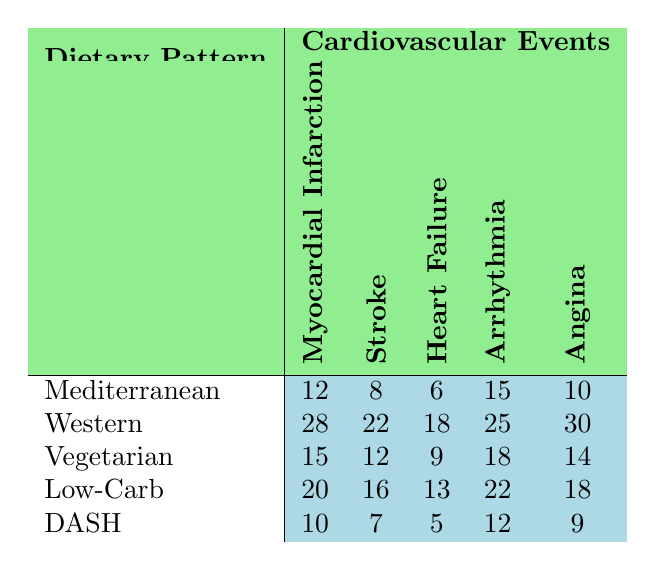What is the frequency of myocardial infarction in the Western dietary pattern? The table shows that for the Western dietary pattern, the frequency of myocardial infarction is listed as 28.
Answer: 28 Which dietary pattern has the highest rate of angina? By comparing the angina values, the Western dietary pattern has the highest value at 30, which is greater than the next highest, Low-Carb at 18.
Answer: Western What is the total number of strokes across all dietary patterns? To find the total strokes, add the values: 8 (Mediterranean) + 22 (Western) + 12 (Vegetarian) + 16 (Low-Carb) + 7 (DASH) = 65.
Answer: 65 Is the frequency of heart failure in the Mediterranean diet higher than that in the DASH diet? In the Mediterranean diet, the frequency of heart failure is 6, while in the DASH diet, it is 5. Since 6 is greater than 5, this statement is true.
Answer: Yes What is the average frequency of arrhythmia across all dietary patterns? First, sum the arrhythmia values: 15 (Mediterranean) + 25 (Western) + 18 (Vegetarian) + 22 (Low-Carb) + 12 (DASH) = 92. There are 5 dietary patterns, so the average is 92/5 = 18.4.
Answer: 18.4 Which dietary pattern has the lowest incidence of heart failure? Looking at the heart failure values, DASH has the lowest frequency at 5, which is less than all other dietary patterns.
Answer: DASH What is the difference in the number of strokes between the Western and the Mediterranean diets? The Western diet has 22 strokes while the Mediterranean has 8. The difference is 22 - 8 = 14.
Answer: 14 How does the frequency of myocardial infarction in the Vegetarian diet compare to that in the Mediterranean diet? The Vegetarian diet's frequency of myocardial infarction is 15, which is greater than the Mediterranean's 12. Therefore, the Vegetarian diet has a higher frequency.
Answer: Higher What dietary pattern has the second highest frequency of arrhythmia? Analyzing the values, the Western diet has 25, Low-Carb has 22, Vegetarian has 18, Mediterranean has 15, and DASH has 12. Hence, Low-Carb has the second highest frequency.
Answer: Low-Carb Is it true that the DASH diet has a lower frequency of angina than the Mediterranean diet? The DASH diet has a frequency of 9 for angina, while the Mediterranean diet has 10. Since 9 is less than 10, the statement is true.
Answer: Yes 